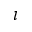Convert formula to latex. <formula><loc_0><loc_0><loc_500><loc_500>\iota</formula> 